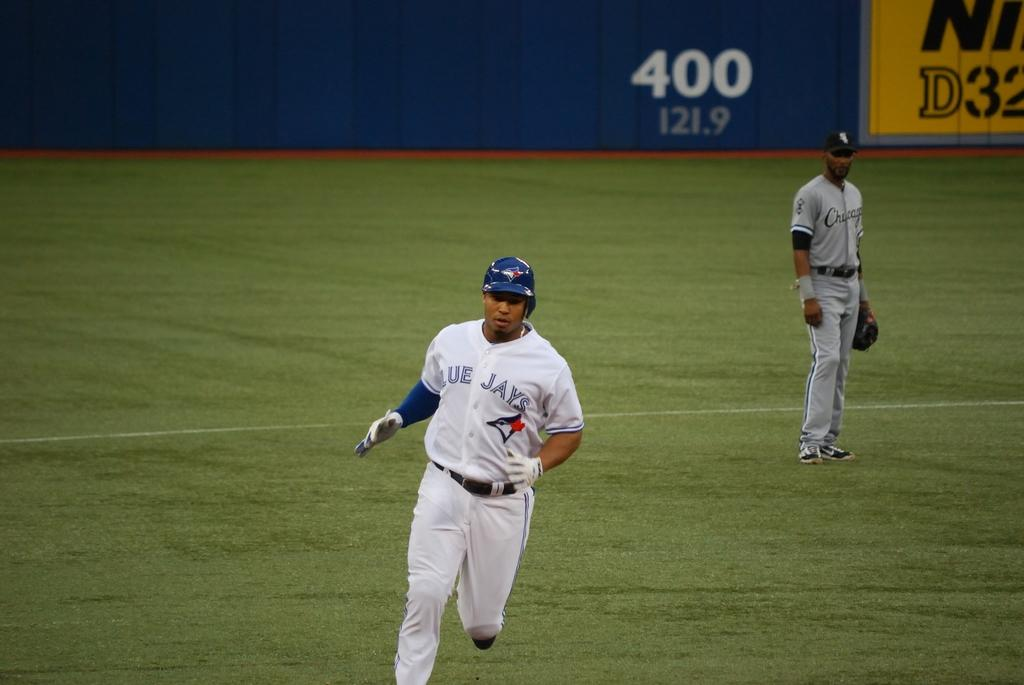Provide a one-sentence caption for the provided image. A Blue Jays player is seen running in the baseball field with a Chicago player in the background and a 400 on the wall. 